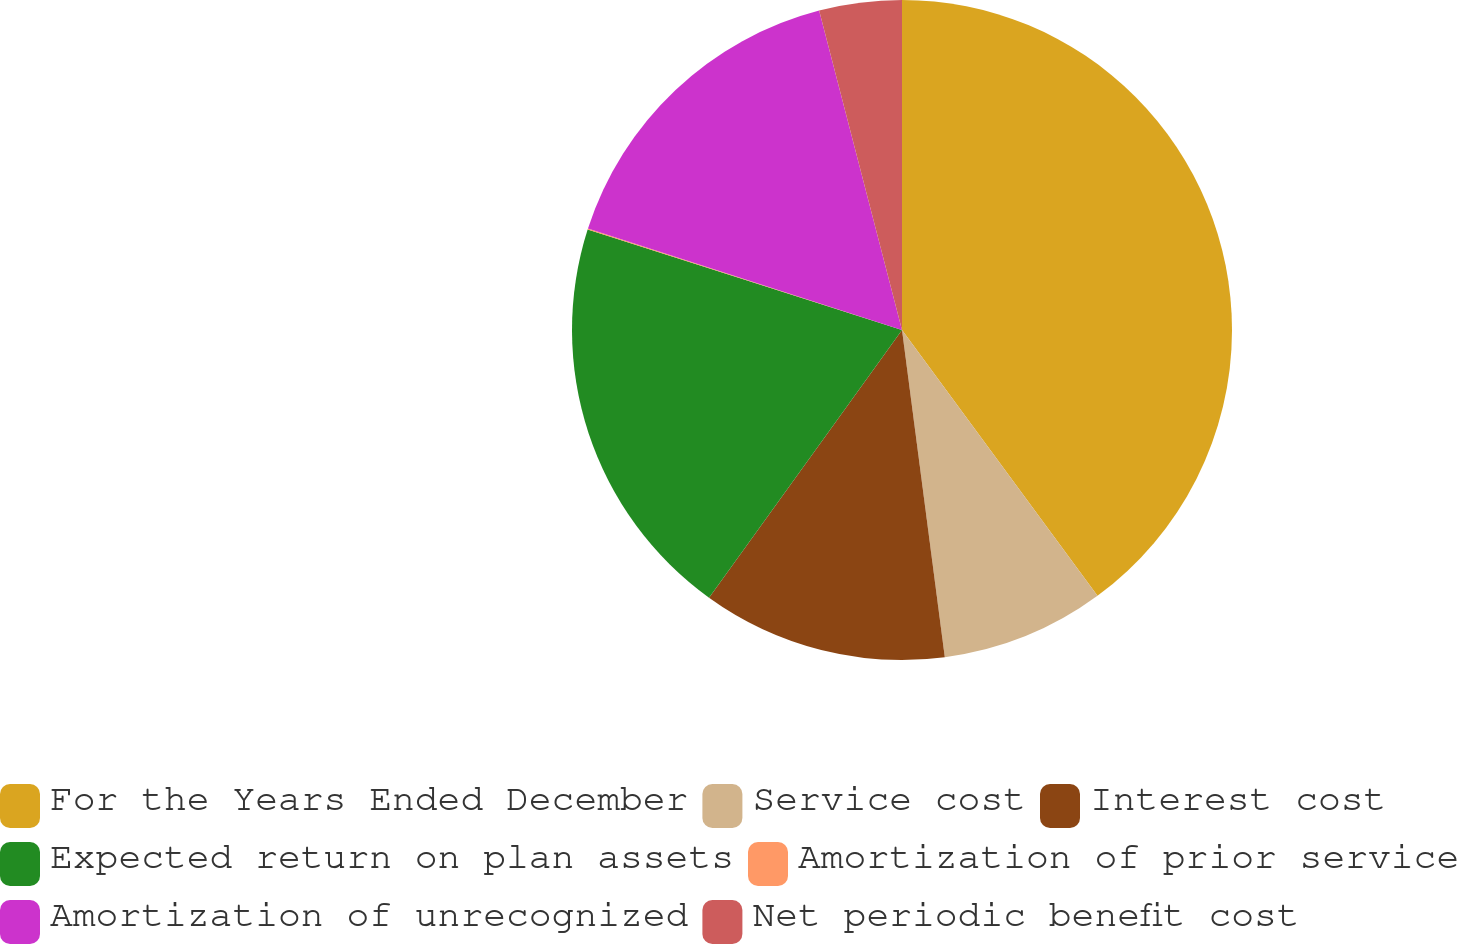Convert chart to OTSL. <chart><loc_0><loc_0><loc_500><loc_500><pie_chart><fcel>For the Years Ended December<fcel>Service cost<fcel>Interest cost<fcel>Expected return on plan assets<fcel>Amortization of prior service<fcel>Amortization of unrecognized<fcel>Net periodic benefit cost<nl><fcel>39.91%<fcel>8.02%<fcel>12.01%<fcel>19.98%<fcel>0.05%<fcel>15.99%<fcel>4.04%<nl></chart> 